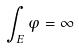<formula> <loc_0><loc_0><loc_500><loc_500>\int _ { E } \varphi = \infty</formula> 